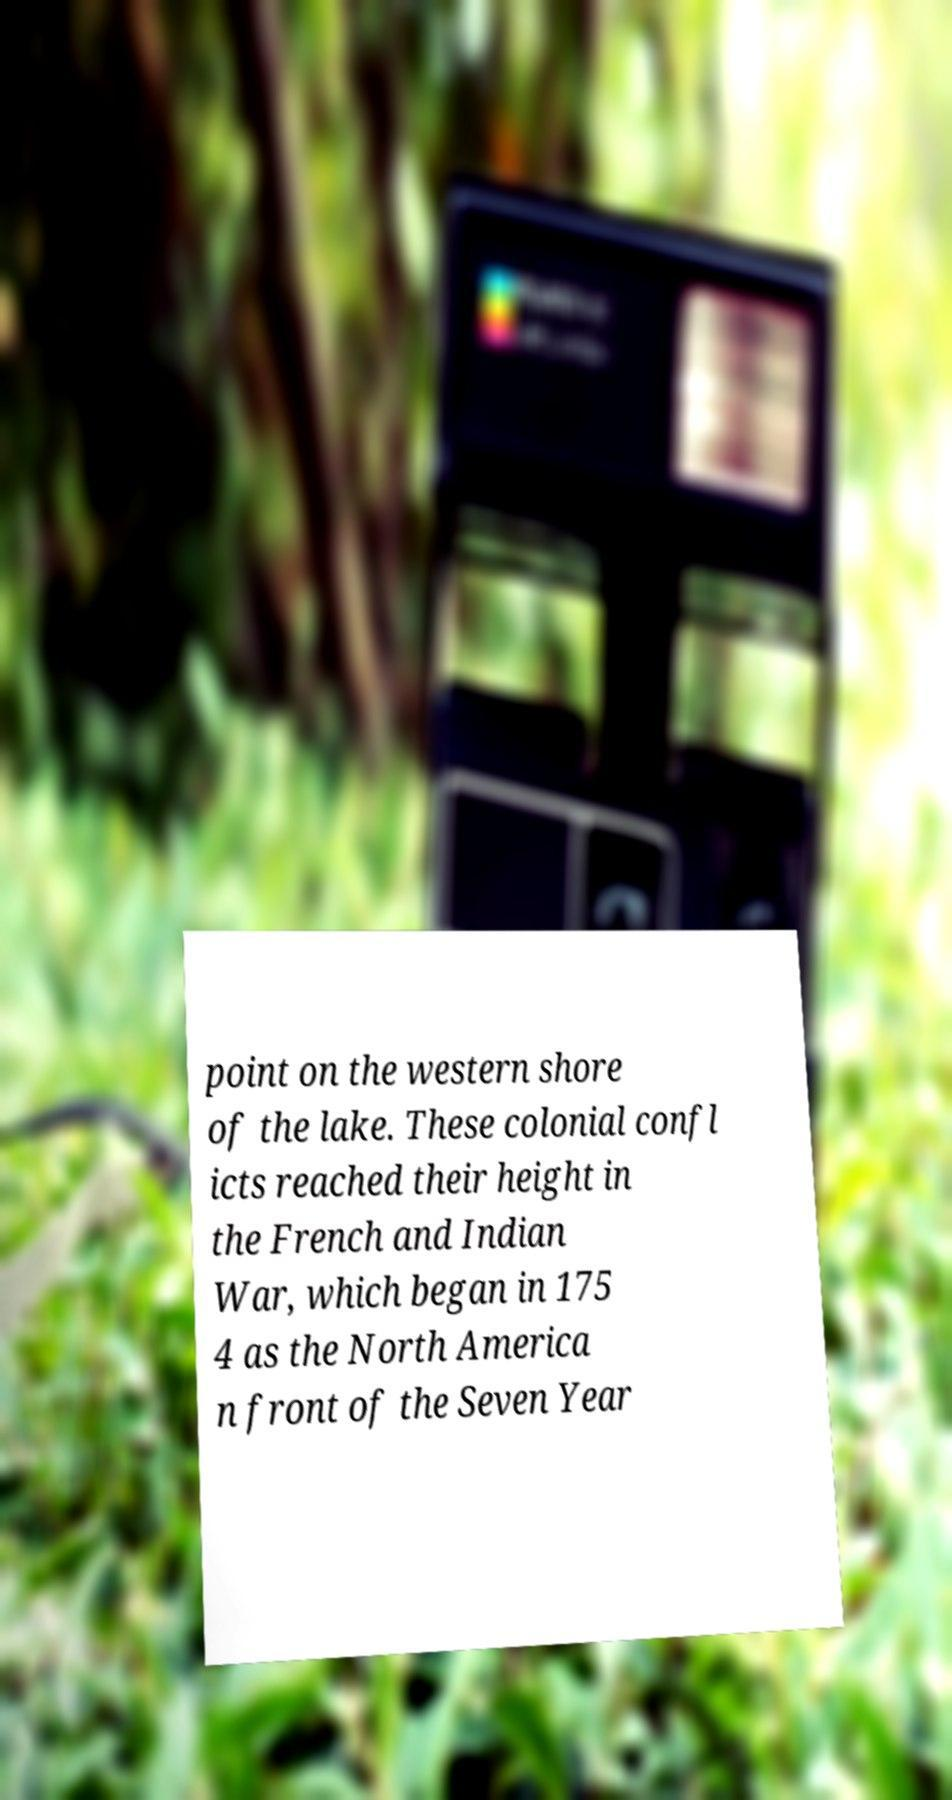Please identify and transcribe the text found in this image. point on the western shore of the lake. These colonial confl icts reached their height in the French and Indian War, which began in 175 4 as the North America n front of the Seven Year 